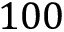Convert formula to latex. <formula><loc_0><loc_0><loc_500><loc_500>1 0 0</formula> 